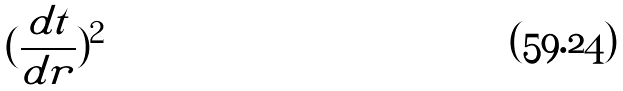Convert formula to latex. <formula><loc_0><loc_0><loc_500><loc_500>( \frac { d t } { d r } ) ^ { 2 }</formula> 